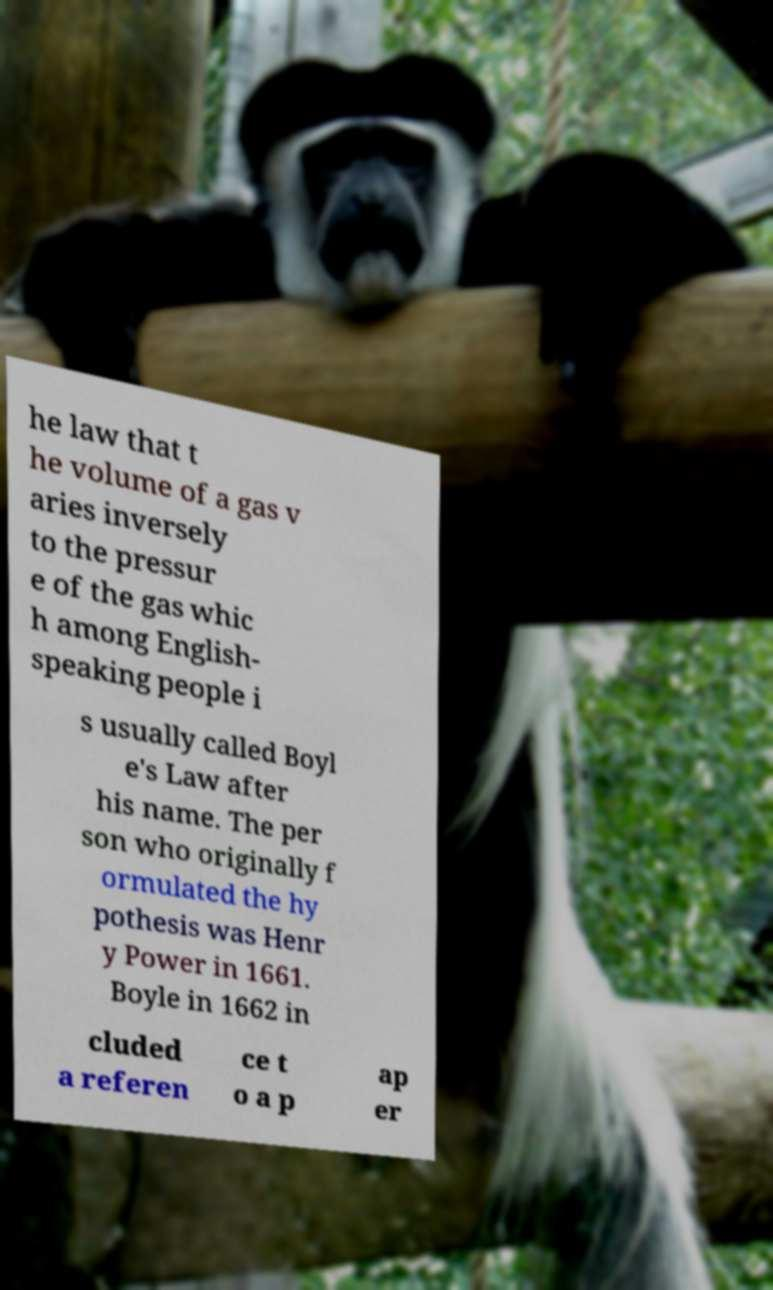For documentation purposes, I need the text within this image transcribed. Could you provide that? he law that t he volume of a gas v aries inversely to the pressur e of the gas whic h among English- speaking people i s usually called Boyl e's Law after his name. The per son who originally f ormulated the hy pothesis was Henr y Power in 1661. Boyle in 1662 in cluded a referen ce t o a p ap er 